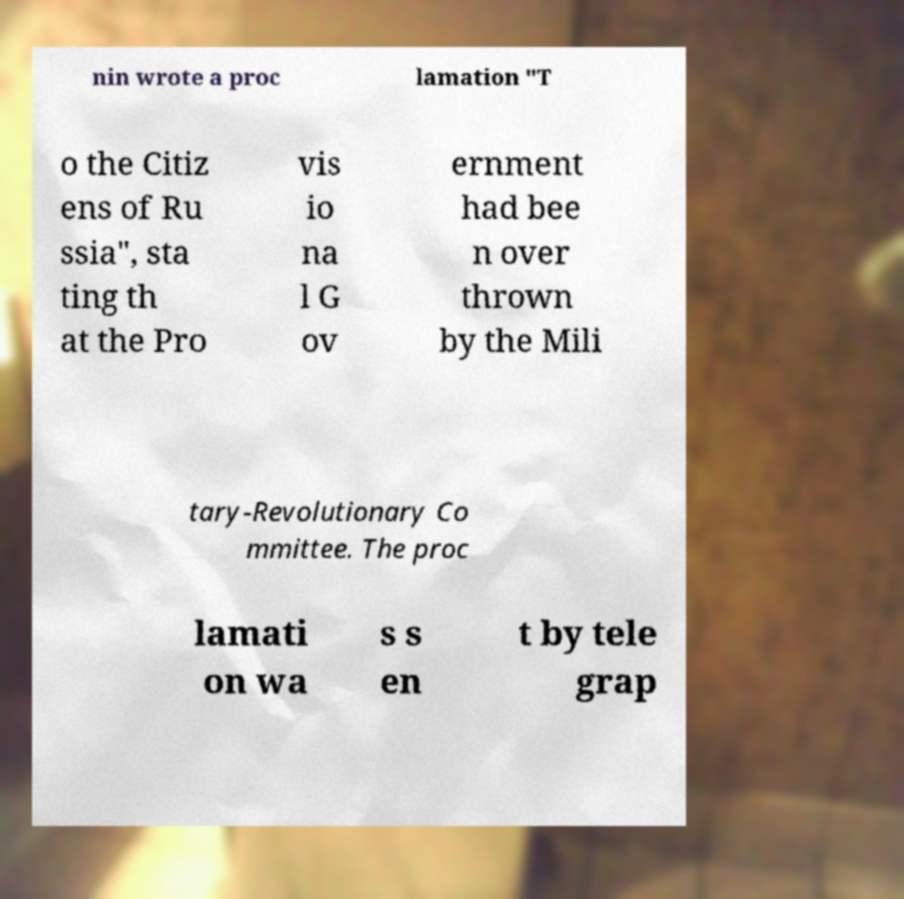Can you read and provide the text displayed in the image?This photo seems to have some interesting text. Can you extract and type it out for me? nin wrote a proc lamation "T o the Citiz ens of Ru ssia", sta ting th at the Pro vis io na l G ov ernment had bee n over thrown by the Mili tary-Revolutionary Co mmittee. The proc lamati on wa s s en t by tele grap 